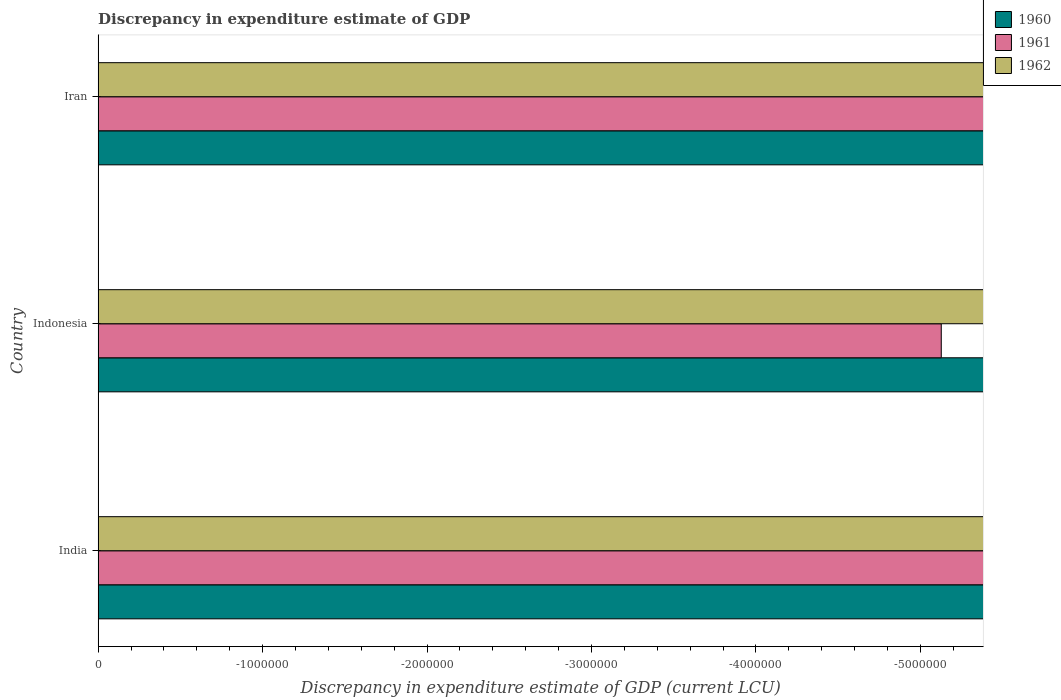Are the number of bars on each tick of the Y-axis equal?
Give a very brief answer. Yes. What is the label of the 1st group of bars from the top?
Your answer should be compact. Iran. Across all countries, what is the minimum discrepancy in expenditure estimate of GDP in 1961?
Your response must be concise. 0. What is the total discrepancy in expenditure estimate of GDP in 1962 in the graph?
Give a very brief answer. 0. What is the difference between the discrepancy in expenditure estimate of GDP in 1961 in Indonesia and the discrepancy in expenditure estimate of GDP in 1960 in Iran?
Offer a terse response. 0. What is the average discrepancy in expenditure estimate of GDP in 1960 per country?
Your answer should be compact. 0. In how many countries, is the discrepancy in expenditure estimate of GDP in 1960 greater than the average discrepancy in expenditure estimate of GDP in 1960 taken over all countries?
Offer a terse response. 0. Does the graph contain grids?
Make the answer very short. No. Where does the legend appear in the graph?
Offer a very short reply. Top right. How are the legend labels stacked?
Give a very brief answer. Vertical. What is the title of the graph?
Your answer should be very brief. Discrepancy in expenditure estimate of GDP. Does "2005" appear as one of the legend labels in the graph?
Your response must be concise. No. What is the label or title of the X-axis?
Make the answer very short. Discrepancy in expenditure estimate of GDP (current LCU). What is the label or title of the Y-axis?
Give a very brief answer. Country. What is the Discrepancy in expenditure estimate of GDP (current LCU) in 1962 in Indonesia?
Provide a succinct answer. 0. What is the Discrepancy in expenditure estimate of GDP (current LCU) of 1960 in Iran?
Your response must be concise. 0. What is the Discrepancy in expenditure estimate of GDP (current LCU) of 1961 in Iran?
Your response must be concise. 0. What is the Discrepancy in expenditure estimate of GDP (current LCU) in 1962 in Iran?
Offer a very short reply. 0. What is the total Discrepancy in expenditure estimate of GDP (current LCU) of 1960 in the graph?
Ensure brevity in your answer.  0. What is the total Discrepancy in expenditure estimate of GDP (current LCU) in 1962 in the graph?
Provide a short and direct response. 0. What is the average Discrepancy in expenditure estimate of GDP (current LCU) of 1960 per country?
Give a very brief answer. 0. What is the average Discrepancy in expenditure estimate of GDP (current LCU) of 1961 per country?
Keep it short and to the point. 0. 